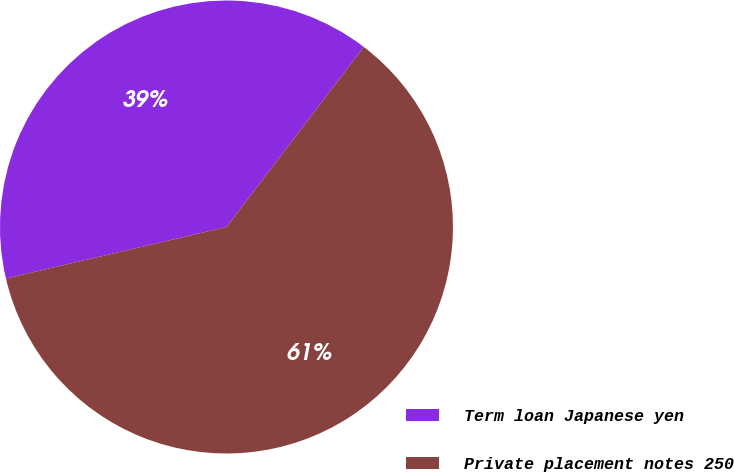<chart> <loc_0><loc_0><loc_500><loc_500><pie_chart><fcel>Term loan Japanese yen<fcel>Private placement notes 250<nl><fcel>39.03%<fcel>60.97%<nl></chart> 